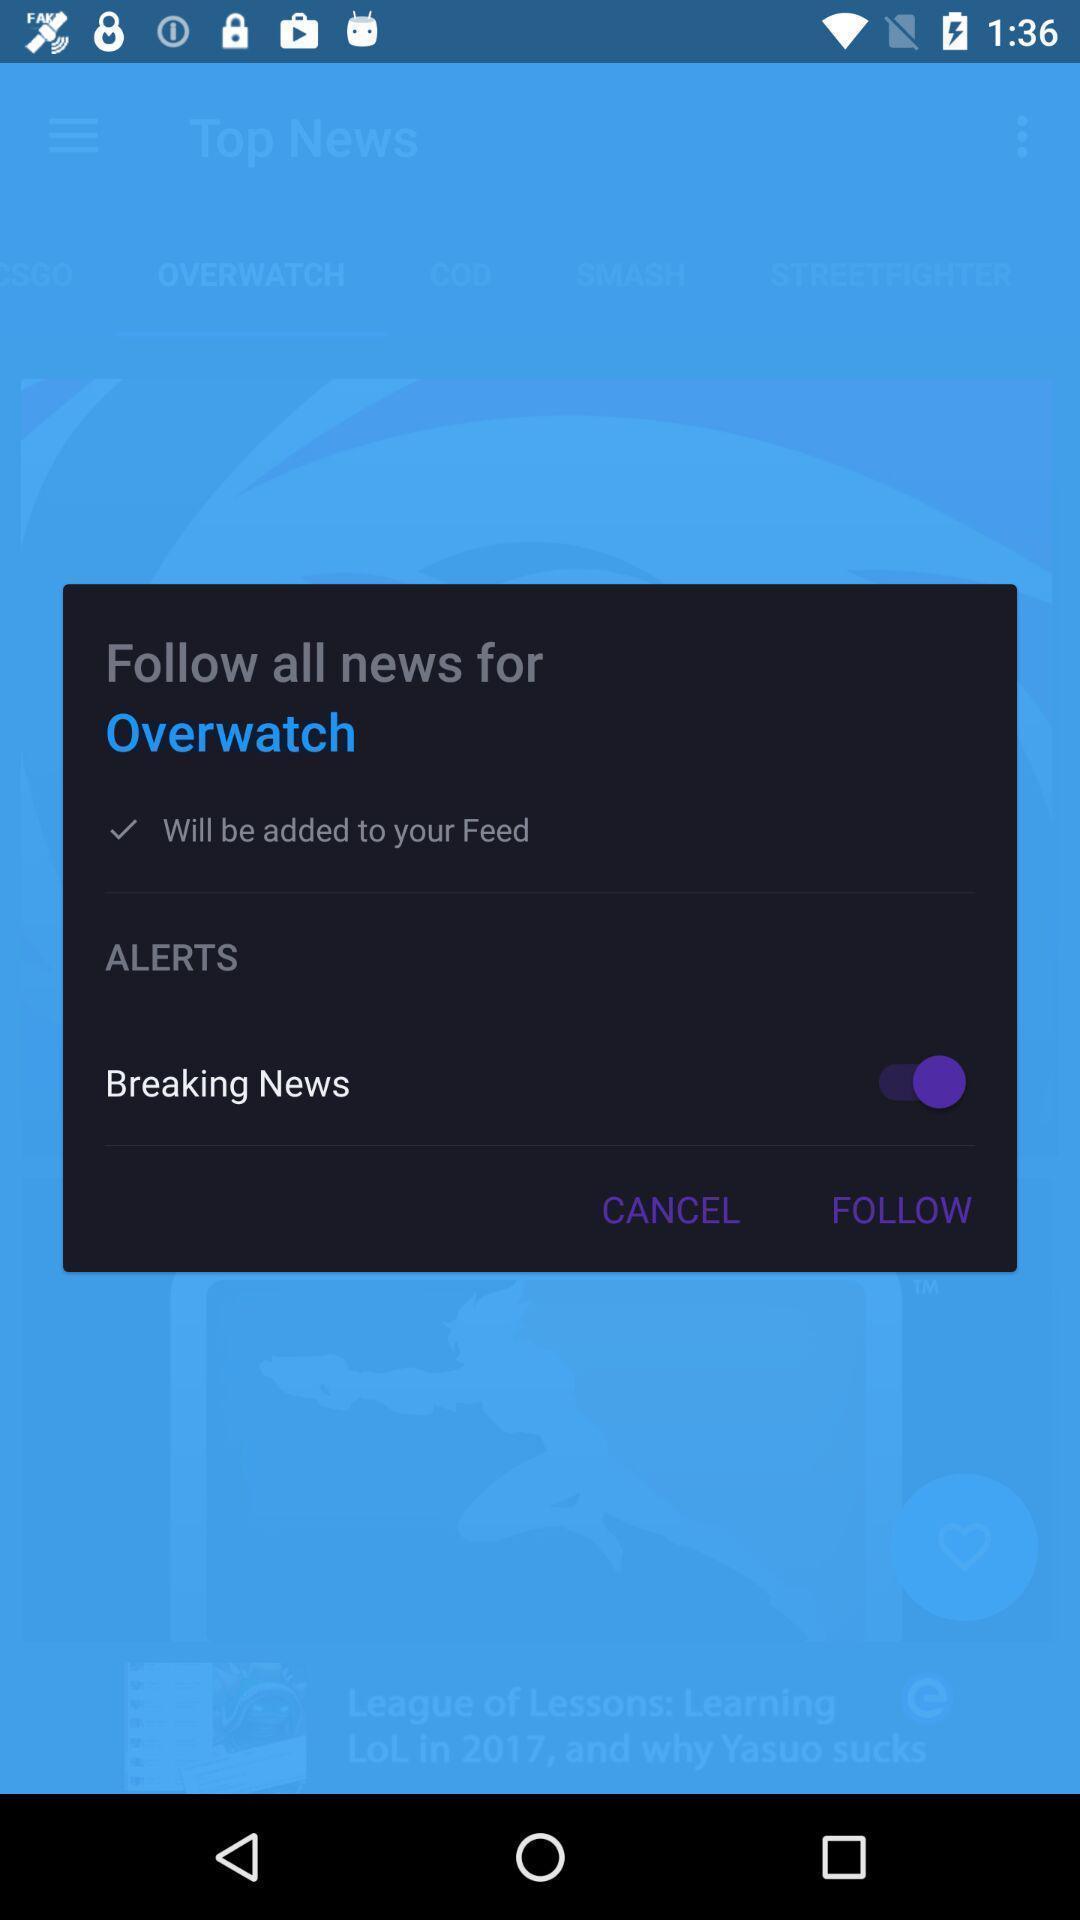What details can you identify in this image? Pop up for adding an alert to application. 